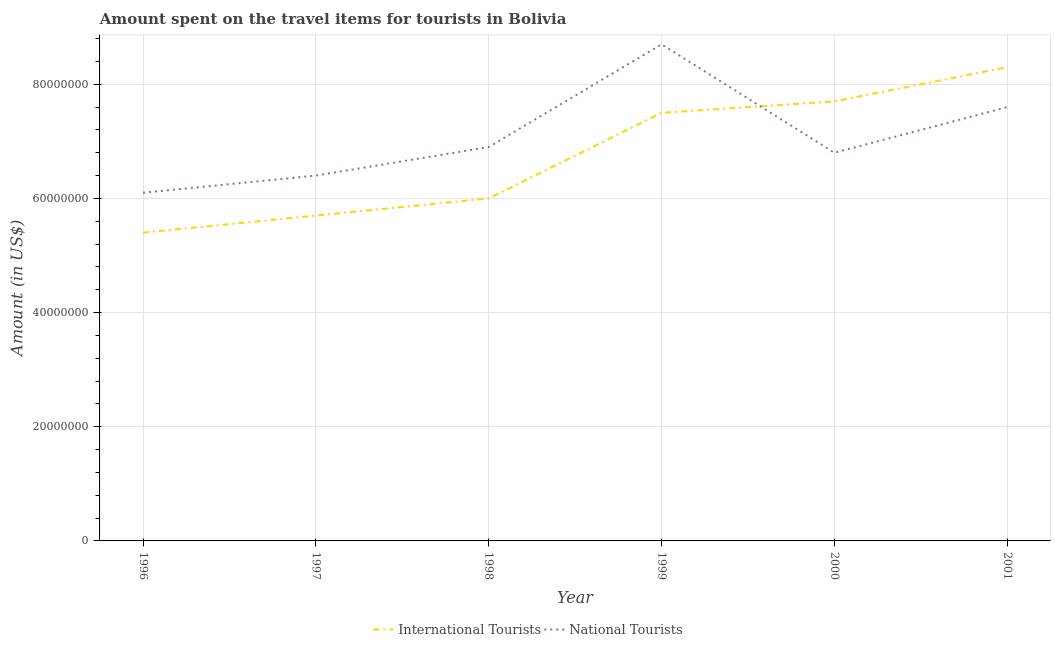What is the amount spent on travel items of international tourists in 1998?
Your answer should be compact. 6.00e+07. Across all years, what is the maximum amount spent on travel items of national tourists?
Keep it short and to the point. 8.70e+07. Across all years, what is the minimum amount spent on travel items of international tourists?
Make the answer very short. 5.40e+07. In which year was the amount spent on travel items of national tourists maximum?
Give a very brief answer. 1999. In which year was the amount spent on travel items of national tourists minimum?
Provide a succinct answer. 1996. What is the total amount spent on travel items of national tourists in the graph?
Make the answer very short. 4.25e+08. What is the difference between the amount spent on travel items of national tourists in 1996 and that in 2001?
Offer a terse response. -1.50e+07. What is the difference between the amount spent on travel items of national tourists in 1997 and the amount spent on travel items of international tourists in 1998?
Ensure brevity in your answer.  4.00e+06. What is the average amount spent on travel items of international tourists per year?
Your response must be concise. 6.77e+07. In the year 2000, what is the difference between the amount spent on travel items of national tourists and amount spent on travel items of international tourists?
Your answer should be compact. -9.00e+06. What is the ratio of the amount spent on travel items of international tourists in 1996 to that in 1999?
Keep it short and to the point. 0.72. Is the difference between the amount spent on travel items of national tourists in 1997 and 1999 greater than the difference between the amount spent on travel items of international tourists in 1997 and 1999?
Your response must be concise. No. What is the difference between the highest and the lowest amount spent on travel items of international tourists?
Offer a terse response. 2.90e+07. In how many years, is the amount spent on travel items of national tourists greater than the average amount spent on travel items of national tourists taken over all years?
Give a very brief answer. 2. Is the sum of the amount spent on travel items of national tourists in 2000 and 2001 greater than the maximum amount spent on travel items of international tourists across all years?
Offer a terse response. Yes. Does the amount spent on travel items of national tourists monotonically increase over the years?
Provide a succinct answer. No. How many lines are there?
Offer a very short reply. 2. How many years are there in the graph?
Your answer should be very brief. 6. What is the difference between two consecutive major ticks on the Y-axis?
Provide a succinct answer. 2.00e+07. Are the values on the major ticks of Y-axis written in scientific E-notation?
Your response must be concise. No. Does the graph contain grids?
Offer a terse response. Yes. Where does the legend appear in the graph?
Give a very brief answer. Bottom center. How many legend labels are there?
Your answer should be compact. 2. What is the title of the graph?
Give a very brief answer. Amount spent on the travel items for tourists in Bolivia. What is the label or title of the X-axis?
Give a very brief answer. Year. What is the Amount (in US$) of International Tourists in 1996?
Provide a short and direct response. 5.40e+07. What is the Amount (in US$) of National Tourists in 1996?
Make the answer very short. 6.10e+07. What is the Amount (in US$) in International Tourists in 1997?
Provide a short and direct response. 5.70e+07. What is the Amount (in US$) of National Tourists in 1997?
Give a very brief answer. 6.40e+07. What is the Amount (in US$) in International Tourists in 1998?
Offer a very short reply. 6.00e+07. What is the Amount (in US$) in National Tourists in 1998?
Provide a succinct answer. 6.90e+07. What is the Amount (in US$) of International Tourists in 1999?
Your response must be concise. 7.50e+07. What is the Amount (in US$) of National Tourists in 1999?
Provide a short and direct response. 8.70e+07. What is the Amount (in US$) in International Tourists in 2000?
Make the answer very short. 7.70e+07. What is the Amount (in US$) in National Tourists in 2000?
Offer a very short reply. 6.80e+07. What is the Amount (in US$) of International Tourists in 2001?
Make the answer very short. 8.30e+07. What is the Amount (in US$) of National Tourists in 2001?
Provide a short and direct response. 7.60e+07. Across all years, what is the maximum Amount (in US$) of International Tourists?
Give a very brief answer. 8.30e+07. Across all years, what is the maximum Amount (in US$) in National Tourists?
Your response must be concise. 8.70e+07. Across all years, what is the minimum Amount (in US$) of International Tourists?
Offer a very short reply. 5.40e+07. Across all years, what is the minimum Amount (in US$) in National Tourists?
Give a very brief answer. 6.10e+07. What is the total Amount (in US$) in International Tourists in the graph?
Your answer should be compact. 4.06e+08. What is the total Amount (in US$) in National Tourists in the graph?
Offer a very short reply. 4.25e+08. What is the difference between the Amount (in US$) in International Tourists in 1996 and that in 1997?
Make the answer very short. -3.00e+06. What is the difference between the Amount (in US$) in National Tourists in 1996 and that in 1997?
Give a very brief answer. -3.00e+06. What is the difference between the Amount (in US$) of International Tourists in 1996 and that in 1998?
Make the answer very short. -6.00e+06. What is the difference between the Amount (in US$) of National Tourists in 1996 and that in 1998?
Offer a very short reply. -8.00e+06. What is the difference between the Amount (in US$) of International Tourists in 1996 and that in 1999?
Provide a short and direct response. -2.10e+07. What is the difference between the Amount (in US$) of National Tourists in 1996 and that in 1999?
Keep it short and to the point. -2.60e+07. What is the difference between the Amount (in US$) of International Tourists in 1996 and that in 2000?
Your answer should be very brief. -2.30e+07. What is the difference between the Amount (in US$) of National Tourists in 1996 and that in 2000?
Keep it short and to the point. -7.00e+06. What is the difference between the Amount (in US$) in International Tourists in 1996 and that in 2001?
Offer a terse response. -2.90e+07. What is the difference between the Amount (in US$) of National Tourists in 1996 and that in 2001?
Your answer should be compact. -1.50e+07. What is the difference between the Amount (in US$) of National Tourists in 1997 and that in 1998?
Keep it short and to the point. -5.00e+06. What is the difference between the Amount (in US$) of International Tourists in 1997 and that in 1999?
Your answer should be very brief. -1.80e+07. What is the difference between the Amount (in US$) in National Tourists in 1997 and that in 1999?
Offer a very short reply. -2.30e+07. What is the difference between the Amount (in US$) in International Tourists in 1997 and that in 2000?
Make the answer very short. -2.00e+07. What is the difference between the Amount (in US$) in International Tourists in 1997 and that in 2001?
Your answer should be compact. -2.60e+07. What is the difference between the Amount (in US$) in National Tourists in 1997 and that in 2001?
Keep it short and to the point. -1.20e+07. What is the difference between the Amount (in US$) of International Tourists in 1998 and that in 1999?
Ensure brevity in your answer.  -1.50e+07. What is the difference between the Amount (in US$) in National Tourists in 1998 and that in 1999?
Offer a terse response. -1.80e+07. What is the difference between the Amount (in US$) in International Tourists in 1998 and that in 2000?
Provide a succinct answer. -1.70e+07. What is the difference between the Amount (in US$) in International Tourists in 1998 and that in 2001?
Give a very brief answer. -2.30e+07. What is the difference between the Amount (in US$) of National Tourists in 1998 and that in 2001?
Your answer should be compact. -7.00e+06. What is the difference between the Amount (in US$) of National Tourists in 1999 and that in 2000?
Your answer should be compact. 1.90e+07. What is the difference between the Amount (in US$) of International Tourists in 1999 and that in 2001?
Offer a very short reply. -8.00e+06. What is the difference between the Amount (in US$) in National Tourists in 1999 and that in 2001?
Give a very brief answer. 1.10e+07. What is the difference between the Amount (in US$) of International Tourists in 2000 and that in 2001?
Your response must be concise. -6.00e+06. What is the difference between the Amount (in US$) in National Tourists in 2000 and that in 2001?
Make the answer very short. -8.00e+06. What is the difference between the Amount (in US$) in International Tourists in 1996 and the Amount (in US$) in National Tourists in 1997?
Provide a short and direct response. -1.00e+07. What is the difference between the Amount (in US$) of International Tourists in 1996 and the Amount (in US$) of National Tourists in 1998?
Keep it short and to the point. -1.50e+07. What is the difference between the Amount (in US$) of International Tourists in 1996 and the Amount (in US$) of National Tourists in 1999?
Offer a terse response. -3.30e+07. What is the difference between the Amount (in US$) of International Tourists in 1996 and the Amount (in US$) of National Tourists in 2000?
Make the answer very short. -1.40e+07. What is the difference between the Amount (in US$) in International Tourists in 1996 and the Amount (in US$) in National Tourists in 2001?
Ensure brevity in your answer.  -2.20e+07. What is the difference between the Amount (in US$) in International Tourists in 1997 and the Amount (in US$) in National Tourists in 1998?
Provide a succinct answer. -1.20e+07. What is the difference between the Amount (in US$) of International Tourists in 1997 and the Amount (in US$) of National Tourists in 1999?
Ensure brevity in your answer.  -3.00e+07. What is the difference between the Amount (in US$) in International Tourists in 1997 and the Amount (in US$) in National Tourists in 2000?
Your answer should be compact. -1.10e+07. What is the difference between the Amount (in US$) of International Tourists in 1997 and the Amount (in US$) of National Tourists in 2001?
Your response must be concise. -1.90e+07. What is the difference between the Amount (in US$) in International Tourists in 1998 and the Amount (in US$) in National Tourists in 1999?
Your response must be concise. -2.70e+07. What is the difference between the Amount (in US$) in International Tourists in 1998 and the Amount (in US$) in National Tourists in 2000?
Offer a very short reply. -8.00e+06. What is the difference between the Amount (in US$) in International Tourists in 1998 and the Amount (in US$) in National Tourists in 2001?
Ensure brevity in your answer.  -1.60e+07. What is the difference between the Amount (in US$) of International Tourists in 1999 and the Amount (in US$) of National Tourists in 2000?
Your answer should be compact. 7.00e+06. What is the difference between the Amount (in US$) of International Tourists in 2000 and the Amount (in US$) of National Tourists in 2001?
Give a very brief answer. 1.00e+06. What is the average Amount (in US$) in International Tourists per year?
Provide a short and direct response. 6.77e+07. What is the average Amount (in US$) in National Tourists per year?
Your response must be concise. 7.08e+07. In the year 1996, what is the difference between the Amount (in US$) of International Tourists and Amount (in US$) of National Tourists?
Give a very brief answer. -7.00e+06. In the year 1997, what is the difference between the Amount (in US$) in International Tourists and Amount (in US$) in National Tourists?
Give a very brief answer. -7.00e+06. In the year 1998, what is the difference between the Amount (in US$) in International Tourists and Amount (in US$) in National Tourists?
Your response must be concise. -9.00e+06. In the year 1999, what is the difference between the Amount (in US$) in International Tourists and Amount (in US$) in National Tourists?
Provide a succinct answer. -1.20e+07. In the year 2000, what is the difference between the Amount (in US$) in International Tourists and Amount (in US$) in National Tourists?
Your response must be concise. 9.00e+06. In the year 2001, what is the difference between the Amount (in US$) in International Tourists and Amount (in US$) in National Tourists?
Your answer should be very brief. 7.00e+06. What is the ratio of the Amount (in US$) of National Tourists in 1996 to that in 1997?
Your response must be concise. 0.95. What is the ratio of the Amount (in US$) in National Tourists in 1996 to that in 1998?
Offer a very short reply. 0.88. What is the ratio of the Amount (in US$) in International Tourists in 1996 to that in 1999?
Your answer should be very brief. 0.72. What is the ratio of the Amount (in US$) of National Tourists in 1996 to that in 1999?
Your response must be concise. 0.7. What is the ratio of the Amount (in US$) in International Tourists in 1996 to that in 2000?
Provide a short and direct response. 0.7. What is the ratio of the Amount (in US$) of National Tourists in 1996 to that in 2000?
Provide a short and direct response. 0.9. What is the ratio of the Amount (in US$) of International Tourists in 1996 to that in 2001?
Offer a very short reply. 0.65. What is the ratio of the Amount (in US$) of National Tourists in 1996 to that in 2001?
Your response must be concise. 0.8. What is the ratio of the Amount (in US$) in International Tourists in 1997 to that in 1998?
Keep it short and to the point. 0.95. What is the ratio of the Amount (in US$) of National Tourists in 1997 to that in 1998?
Offer a very short reply. 0.93. What is the ratio of the Amount (in US$) in International Tourists in 1997 to that in 1999?
Ensure brevity in your answer.  0.76. What is the ratio of the Amount (in US$) of National Tourists in 1997 to that in 1999?
Give a very brief answer. 0.74. What is the ratio of the Amount (in US$) in International Tourists in 1997 to that in 2000?
Keep it short and to the point. 0.74. What is the ratio of the Amount (in US$) of International Tourists in 1997 to that in 2001?
Keep it short and to the point. 0.69. What is the ratio of the Amount (in US$) of National Tourists in 1997 to that in 2001?
Your answer should be very brief. 0.84. What is the ratio of the Amount (in US$) of International Tourists in 1998 to that in 1999?
Ensure brevity in your answer.  0.8. What is the ratio of the Amount (in US$) of National Tourists in 1998 to that in 1999?
Provide a short and direct response. 0.79. What is the ratio of the Amount (in US$) of International Tourists in 1998 to that in 2000?
Give a very brief answer. 0.78. What is the ratio of the Amount (in US$) in National Tourists in 1998 to that in 2000?
Offer a terse response. 1.01. What is the ratio of the Amount (in US$) in International Tourists in 1998 to that in 2001?
Your answer should be very brief. 0.72. What is the ratio of the Amount (in US$) in National Tourists in 1998 to that in 2001?
Provide a succinct answer. 0.91. What is the ratio of the Amount (in US$) of National Tourists in 1999 to that in 2000?
Offer a very short reply. 1.28. What is the ratio of the Amount (in US$) of International Tourists in 1999 to that in 2001?
Ensure brevity in your answer.  0.9. What is the ratio of the Amount (in US$) in National Tourists in 1999 to that in 2001?
Your response must be concise. 1.14. What is the ratio of the Amount (in US$) in International Tourists in 2000 to that in 2001?
Your response must be concise. 0.93. What is the ratio of the Amount (in US$) in National Tourists in 2000 to that in 2001?
Your response must be concise. 0.89. What is the difference between the highest and the second highest Amount (in US$) in National Tourists?
Offer a terse response. 1.10e+07. What is the difference between the highest and the lowest Amount (in US$) in International Tourists?
Provide a succinct answer. 2.90e+07. What is the difference between the highest and the lowest Amount (in US$) in National Tourists?
Your response must be concise. 2.60e+07. 